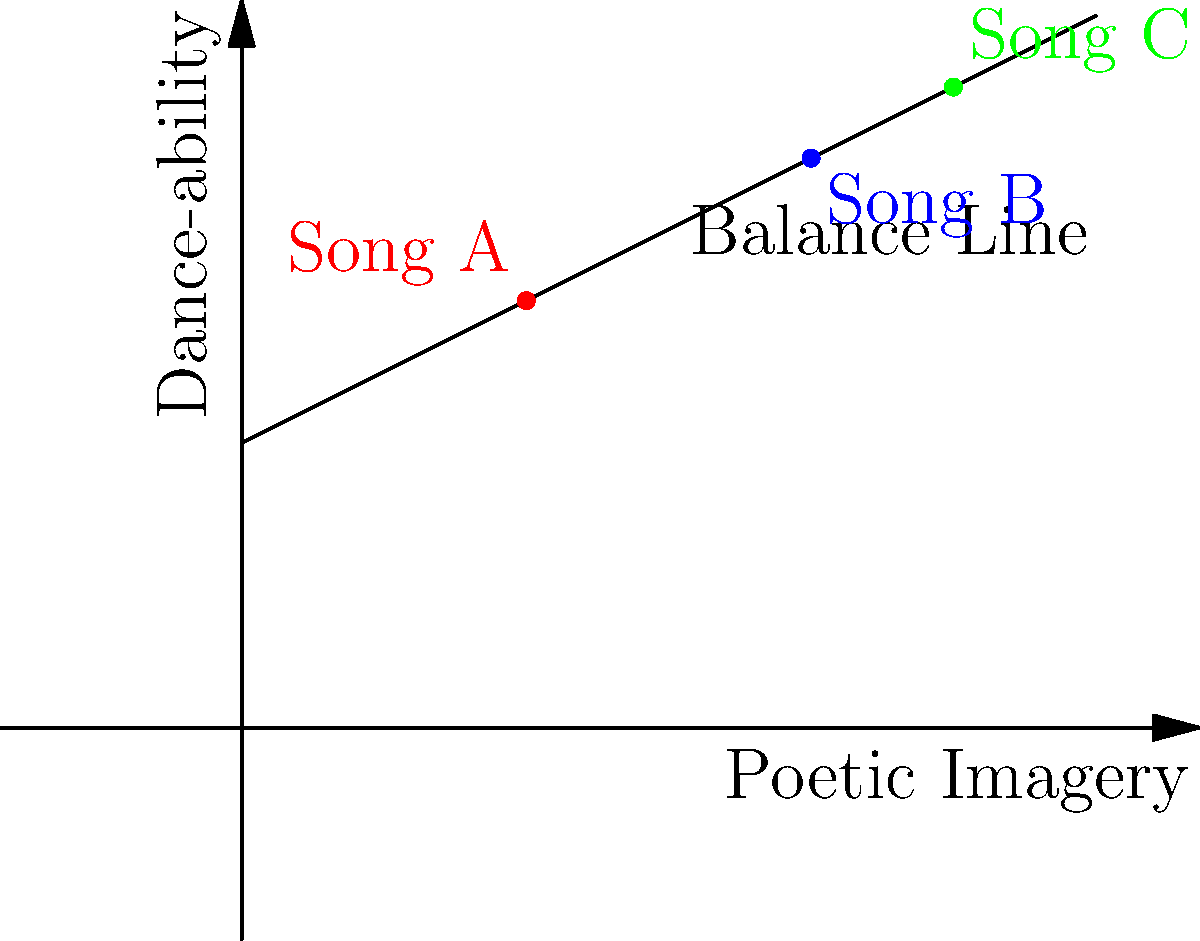Consider the weighted scale graphic representing the balance between poetic imagery and dance-ability in lyrical dance music. Which song achieves the best balance according to this model, and why? To determine the best balance between poetic imagery and dance-ability, we need to analyze the position of each song relative to the balance line:

1. The balance line represents the ideal combination of poetic imagery and dance-ability.
2. Songs closer to this line have a better balance between the two elements.

Let's examine each song:

1. Song A (red dot):
   - Coordinates approximately (2, 3)
   - Below the balance line
   - Indicates higher dance-ability relative to poetic imagery

2. Song B (blue dot):
   - Coordinates approximately (4, 4)
   - Very close to the balance line
   - Indicates a near-perfect balance between poetic imagery and dance-ability

3. Song C (green dot):
   - Coordinates approximately (5, 4.5)
   - Slightly above the balance line
   - Indicates slightly higher poetic imagery relative to dance-ability

Comparing the three songs, Song B is closest to the balance line, representing the best equilibrium between poetic imagery and dance-ability.
Answer: Song B 